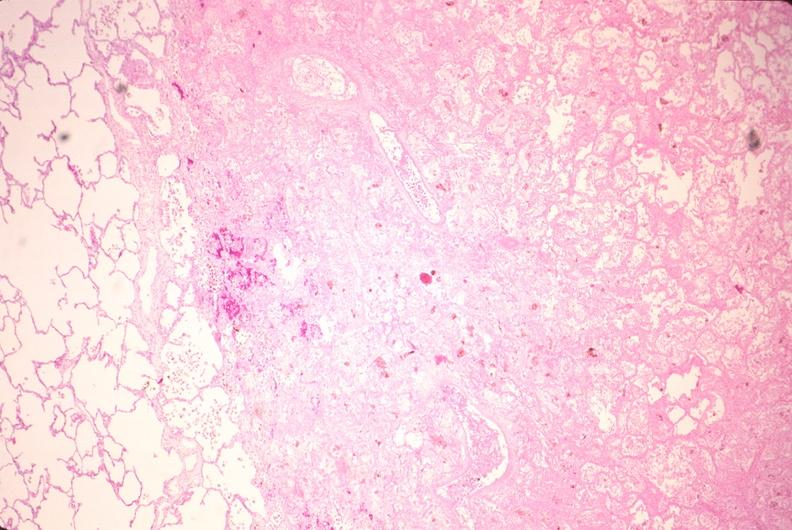does this image show lung, infarct, acute and organized?
Answer the question using a single word or phrase. Yes 